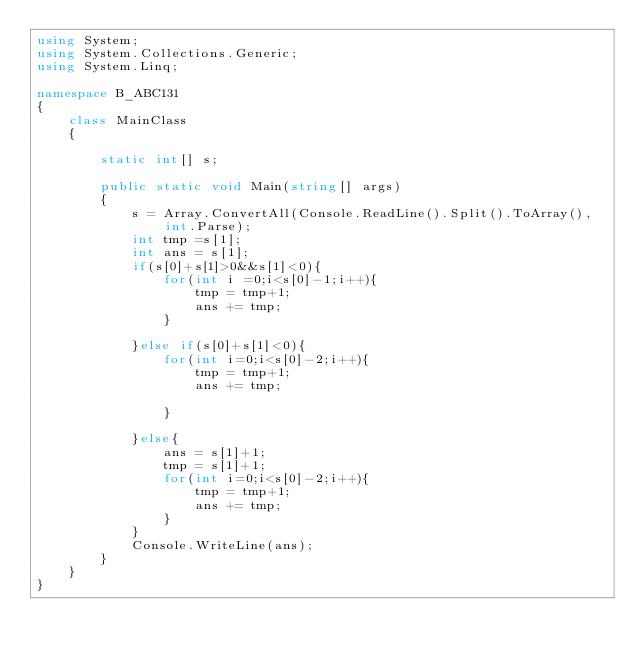Convert code to text. <code><loc_0><loc_0><loc_500><loc_500><_C#_>using System;
using System.Collections.Generic;
using System.Linq;

namespace B_ABC131
{
    class MainClass
    {

        static int[] s;

        public static void Main(string[] args)
        {
            s = Array.ConvertAll(Console.ReadLine().Split().ToArray(), int.Parse);
            int tmp =s[1];
            int ans = s[1];
            if(s[0]+s[1]>0&&s[1]<0){
                for(int i =0;i<s[0]-1;i++){
                    tmp = tmp+1;
                    ans += tmp;
                }

            }else if(s[0]+s[1]<0){
                for(int i=0;i<s[0]-2;i++){
                    tmp = tmp+1;
                    ans += tmp;

                }

            }else{
                ans = s[1]+1;
                tmp = s[1]+1;
                for(int i=0;i<s[0]-2;i++){
                    tmp = tmp+1;
                    ans += tmp;
                }
            }
            Console.WriteLine(ans);
        }
    }
}
</code> 